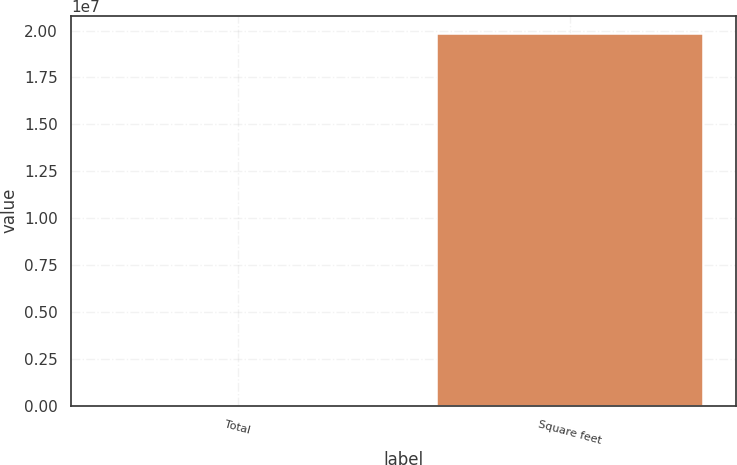Convert chart. <chart><loc_0><loc_0><loc_500><loc_500><bar_chart><fcel>Total<fcel>Square feet<nl><fcel>255<fcel>1.9796e+07<nl></chart> 